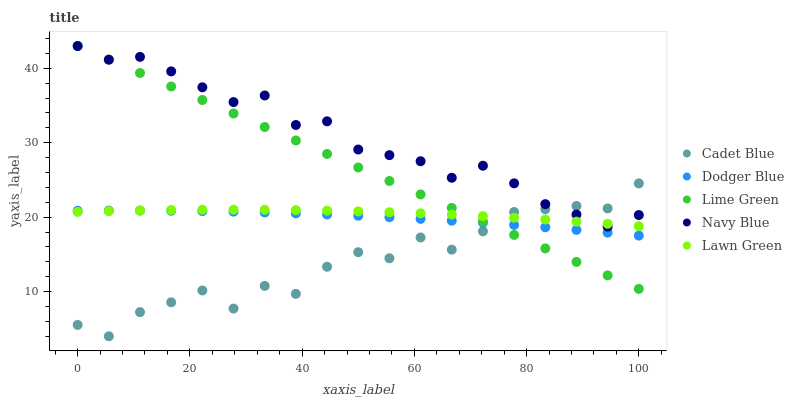Does Cadet Blue have the minimum area under the curve?
Answer yes or no. Yes. Does Navy Blue have the maximum area under the curve?
Answer yes or no. Yes. Does Dodger Blue have the minimum area under the curve?
Answer yes or no. No. Does Dodger Blue have the maximum area under the curve?
Answer yes or no. No. Is Lime Green the smoothest?
Answer yes or no. Yes. Is Cadet Blue the roughest?
Answer yes or no. Yes. Is Dodger Blue the smoothest?
Answer yes or no. No. Is Dodger Blue the roughest?
Answer yes or no. No. Does Cadet Blue have the lowest value?
Answer yes or no. Yes. Does Dodger Blue have the lowest value?
Answer yes or no. No. Does Navy Blue have the highest value?
Answer yes or no. Yes. Does Cadet Blue have the highest value?
Answer yes or no. No. Is Dodger Blue less than Navy Blue?
Answer yes or no. Yes. Is Navy Blue greater than Dodger Blue?
Answer yes or no. Yes. Does Navy Blue intersect Lime Green?
Answer yes or no. Yes. Is Navy Blue less than Lime Green?
Answer yes or no. No. Is Navy Blue greater than Lime Green?
Answer yes or no. No. Does Dodger Blue intersect Navy Blue?
Answer yes or no. No. 